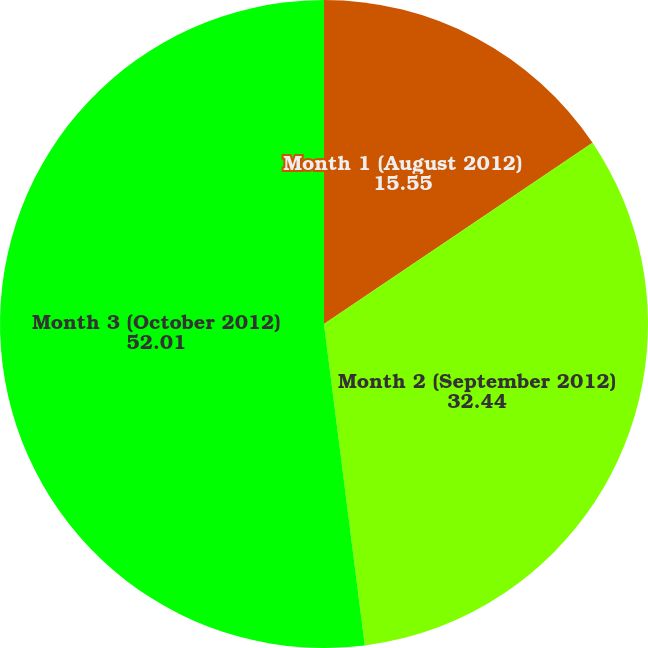Convert chart. <chart><loc_0><loc_0><loc_500><loc_500><pie_chart><fcel>Month 1 (August 2012)<fcel>Month 2 (September 2012)<fcel>Month 3 (October 2012)<nl><fcel>15.55%<fcel>32.44%<fcel>52.01%<nl></chart> 